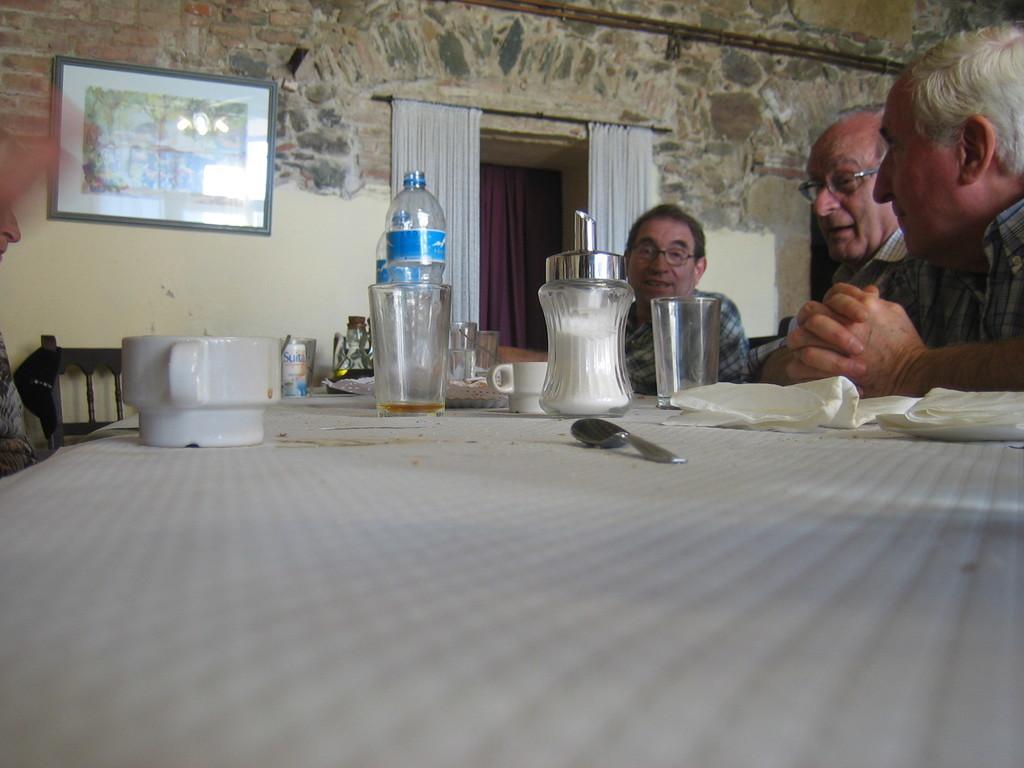Please provide a concise description of this image. In this picture we can see cups, bottles, glasses, spoons, tissues on the table, in front of the table few people are seated on the chairs, in the background we can see wall painting and couple of curtains. 